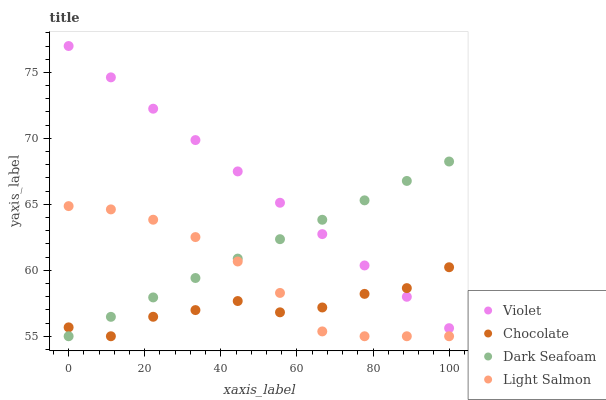Does Chocolate have the minimum area under the curve?
Answer yes or no. Yes. Does Violet have the maximum area under the curve?
Answer yes or no. Yes. Does Light Salmon have the minimum area under the curve?
Answer yes or no. No. Does Light Salmon have the maximum area under the curve?
Answer yes or no. No. Is Violet the smoothest?
Answer yes or no. Yes. Is Chocolate the roughest?
Answer yes or no. Yes. Is Light Salmon the smoothest?
Answer yes or no. No. Is Light Salmon the roughest?
Answer yes or no. No. Does Dark Seafoam have the lowest value?
Answer yes or no. Yes. Does Violet have the lowest value?
Answer yes or no. No. Does Violet have the highest value?
Answer yes or no. Yes. Does Light Salmon have the highest value?
Answer yes or no. No. Is Light Salmon less than Violet?
Answer yes or no. Yes. Is Violet greater than Light Salmon?
Answer yes or no. Yes. Does Light Salmon intersect Dark Seafoam?
Answer yes or no. Yes. Is Light Salmon less than Dark Seafoam?
Answer yes or no. No. Is Light Salmon greater than Dark Seafoam?
Answer yes or no. No. Does Light Salmon intersect Violet?
Answer yes or no. No. 